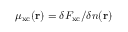<formula> <loc_0><loc_0><loc_500><loc_500>\mu _ { x c } ( r ) = \delta F _ { x c } / \delta n ( r )</formula> 